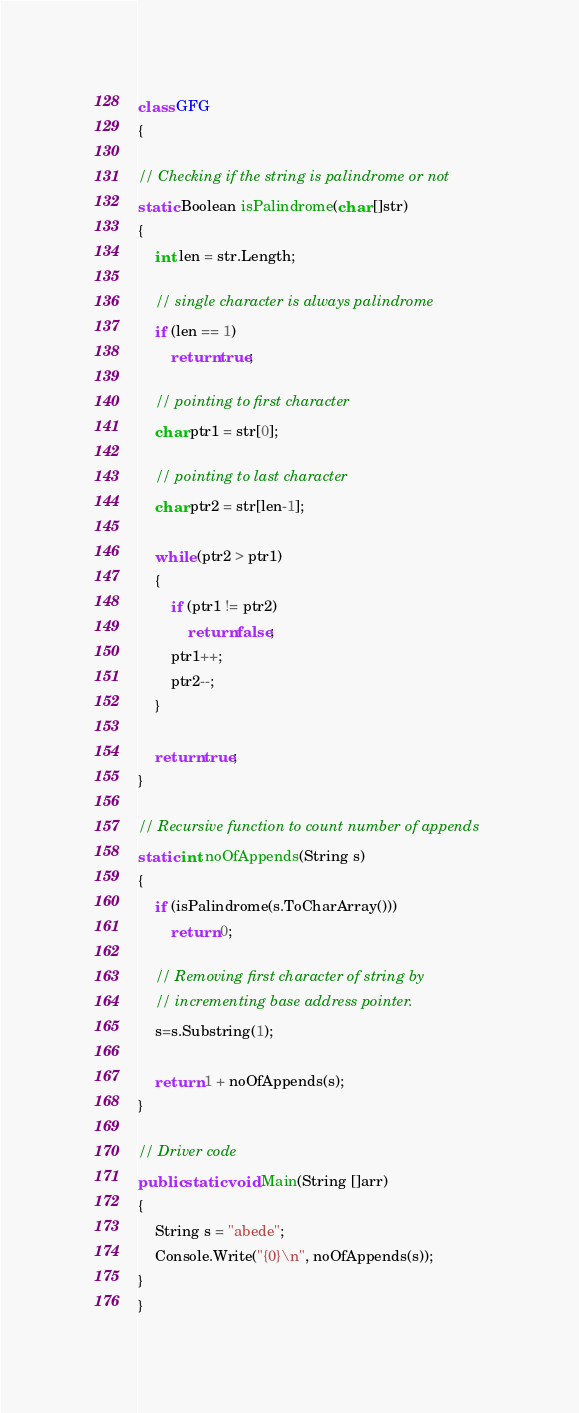<code> <loc_0><loc_0><loc_500><loc_500><_C#_>class GFG  
{  
  
// Checking if the string is palindrome or not  
static Boolean isPalindrome(char []str)  
{  
    int len = str.Length;  
  
    // single character is always palindrome  
    if (len == 1)  
        return true;  
  
    // pointing to first character  
    char ptr1 = str[0];  
  
    // pointing to last character  
    char ptr2 = str[len-1];  
  
    while (ptr2 > ptr1)  
    {  
        if (ptr1 != ptr2)  
            return false;  
        ptr1++;  
        ptr2--;  
    }  
  
    return true;  
}  
  
// Recursive function to count number of appends  
static int noOfAppends(String s)  
{  
    if (isPalindrome(s.ToCharArray()))  
        return 0;  
  
    // Removing first character of string by  
    // incrementing base address pointer.  
    s=s.Substring(1);  
  
    return 1 + noOfAppends(s);  
}  
  
// Driver code  
public static void Main(String []arr)  
{  
    String s = "abede";  
    Console.Write("{0}\n", noOfAppends(s));  
}  
} </code> 